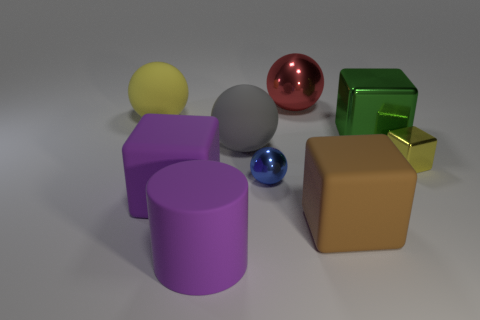What is the material of the small ball that is to the right of the big block that is to the left of the metallic object that is on the left side of the big red metallic object?
Your response must be concise. Metal. Is the size of the thing that is behind the yellow ball the same as the large gray sphere?
Keep it short and to the point. Yes. How many large objects are cyan matte objects or purple cylinders?
Give a very brief answer. 1. Is there a rubber object of the same color as the rubber cylinder?
Your response must be concise. Yes. What shape is the blue thing that is the same size as the yellow metal object?
Provide a succinct answer. Sphere. Does the big rubber object behind the big green thing have the same color as the small block?
Keep it short and to the point. Yes. What number of objects are yellow objects that are behind the large gray matte ball or cyan metallic cubes?
Provide a short and direct response. 1. Is the number of large rubber cubes that are on the left side of the brown rubber thing greater than the number of large purple things behind the large gray sphere?
Make the answer very short. Yes. Do the big yellow object and the gray ball have the same material?
Provide a succinct answer. Yes. There is a big thing that is both behind the green cube and on the left side of the small sphere; what shape is it?
Your answer should be compact. Sphere. 